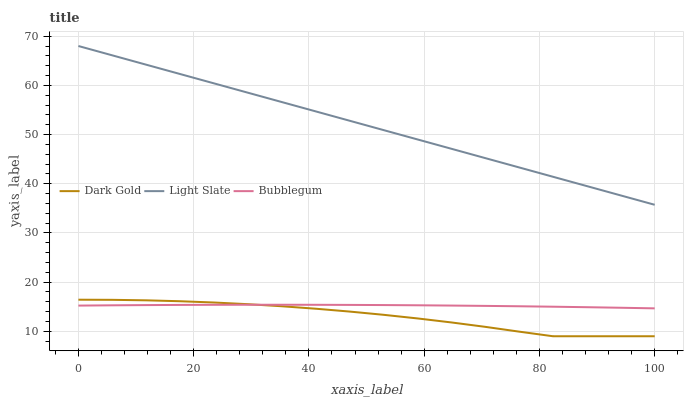Does Dark Gold have the minimum area under the curve?
Answer yes or no. Yes. Does Light Slate have the maximum area under the curve?
Answer yes or no. Yes. Does Bubblegum have the minimum area under the curve?
Answer yes or no. No. Does Bubblegum have the maximum area under the curve?
Answer yes or no. No. Is Light Slate the smoothest?
Answer yes or no. Yes. Is Dark Gold the roughest?
Answer yes or no. Yes. Is Bubblegum the smoothest?
Answer yes or no. No. Is Bubblegum the roughest?
Answer yes or no. No. Does Bubblegum have the lowest value?
Answer yes or no. No. Does Light Slate have the highest value?
Answer yes or no. Yes. Does Dark Gold have the highest value?
Answer yes or no. No. Is Bubblegum less than Light Slate?
Answer yes or no. Yes. Is Light Slate greater than Bubblegum?
Answer yes or no. Yes. Does Dark Gold intersect Bubblegum?
Answer yes or no. Yes. Is Dark Gold less than Bubblegum?
Answer yes or no. No. Is Dark Gold greater than Bubblegum?
Answer yes or no. No. Does Bubblegum intersect Light Slate?
Answer yes or no. No. 